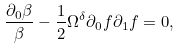Convert formula to latex. <formula><loc_0><loc_0><loc_500><loc_500>\frac { \partial _ { 0 } \beta } { \beta } - \frac { 1 } { 2 } \Omega ^ { \delta } \partial _ { 0 } f \partial _ { 1 } f = 0 ,</formula> 